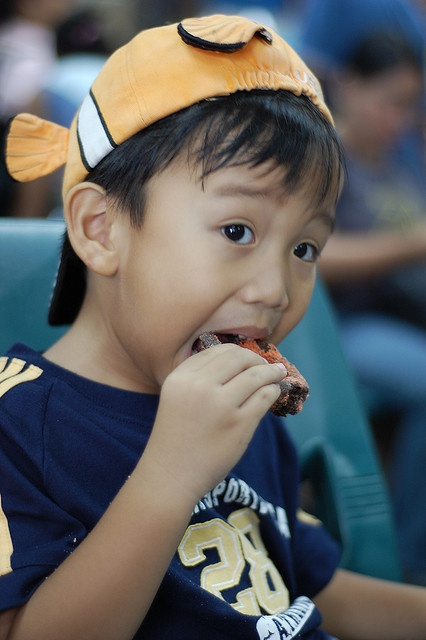Describe the objects in this image and their specific colors. I can see people in black, darkgray, and gray tones, people in black, gray, navy, and blue tones, and donut in black, gray, and darkgray tones in this image. 